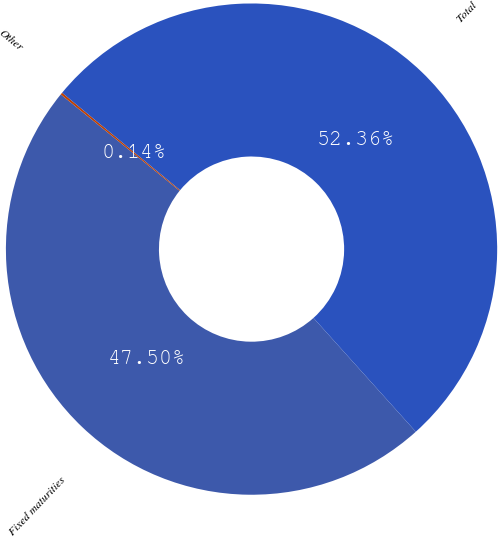<chart> <loc_0><loc_0><loc_500><loc_500><pie_chart><fcel>Fixed maturities<fcel>Other<fcel>Total<nl><fcel>47.5%<fcel>0.14%<fcel>52.36%<nl></chart> 